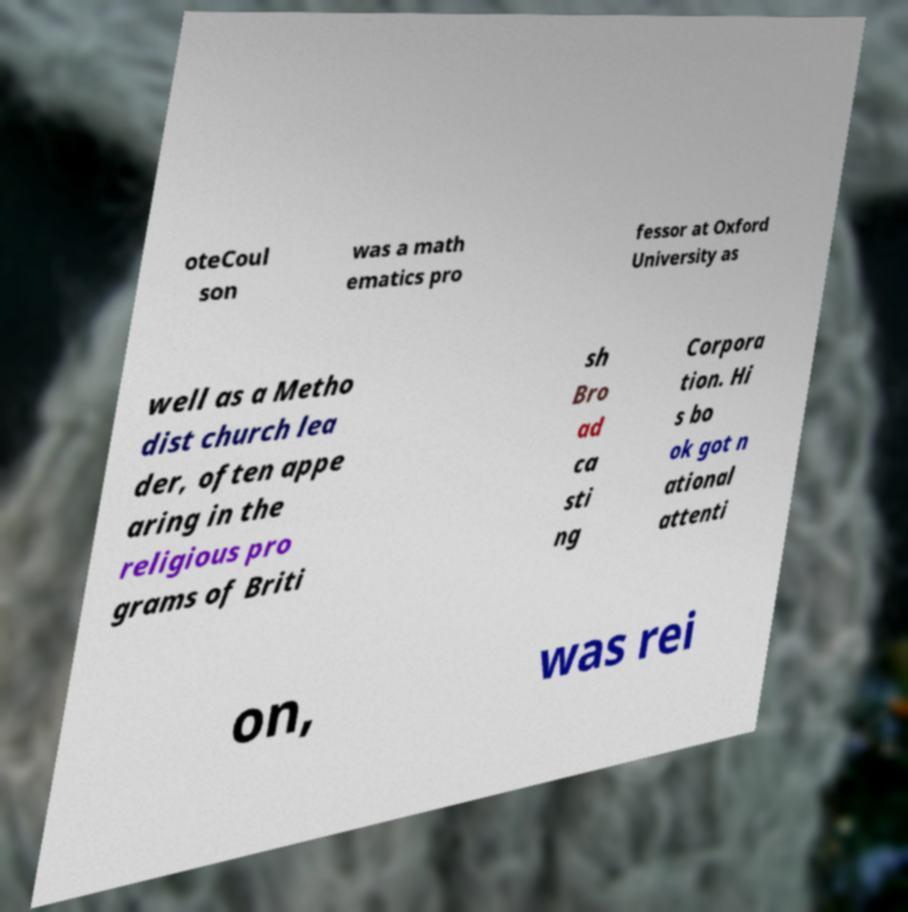What messages or text are displayed in this image? I need them in a readable, typed format. oteCoul son was a math ematics pro fessor at Oxford University as well as a Metho dist church lea der, often appe aring in the religious pro grams of Briti sh Bro ad ca sti ng Corpora tion. Hi s bo ok got n ational attenti on, was rei 